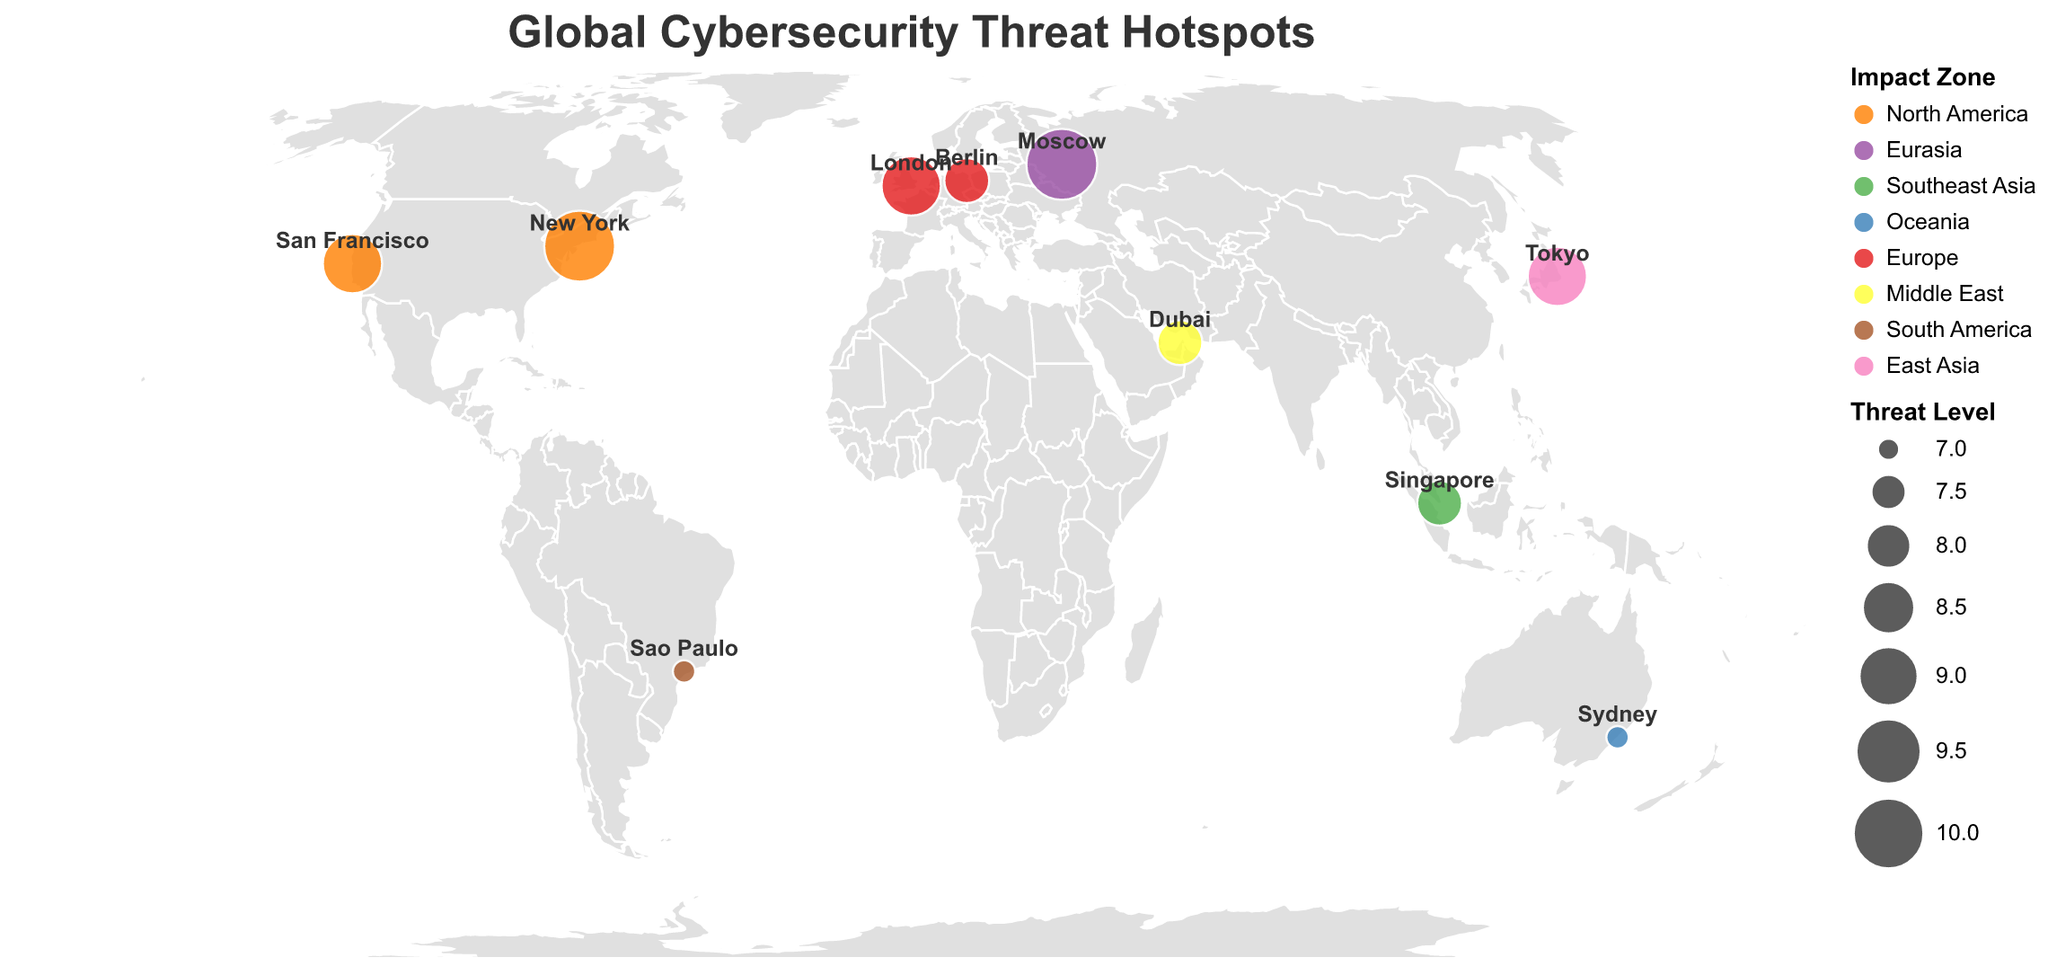What does the title of the figure say? The title of the figure is prominently displayed at the top and helps in immediately understanding the context of the map, which is about cybersecurity threats.
Answer: Global Cybersecurity Threat Hotspots How many hotspots are represented on the map? By counting the number of marked locations on the map, we can determine the total number of hotspots represented.
Answer: 10 Which region corresponds to AI-powered honeypots as an unconventional approach? By looking at the tooltip or by identifying San Francisco on the map and referencing its associated unconventional approach.
Answer: North America Which two regions have the highest threat levels and what unconventional approaches are used there? By identifying the hotspots with the highest threat levels (Moscow and New York) and checking their corresponding unconventional approaches.
Answer: Eurasia: Quantum-resistant encryption, North America: Cognitive security operations What's the average threat level among all the hotspots? Sum the threat levels of all hotspots (9+10+8+7+9+8+7+9+10+8 = 85), and divide by the number of hotspots (10).
Answer: 8.5 Compare the threat levels of Singapore and Sydney. Which one is higher? Locate Singapore and Sydney on the map, note their threat levels, and compare them.
Answer: Singapore is higher Which regions from the map are involved in using biometric behavior analysis as a part of their cybersecurity measures? Look for the hotspot with the unconventional approach "Biometric behavior analysis" (Sydney) and then identify its region.
Answer: Oceania What is the difference between the threat levels of the highest and lowest hotspot? Identify the highest (Moscow, New York - 10 each) and the lowest (Sydney, Sao Paulo - 7 each), and calculate the difference.
Answer: 3 Which hotspot falls under the Southeast Asia impact zone, and what is its unconventional approach? Identify the hotspot in the Southeast Asia region (Singapore) and look up its unconventional approach.
Answer: Blockchain-based authentication Which European countries are represented on the map, and what are their associated threat levels? Locate all countries within the Europe impact zone on the map and note their threat levels (London, Berlin).
Answer: London: 9, Berlin: 8 